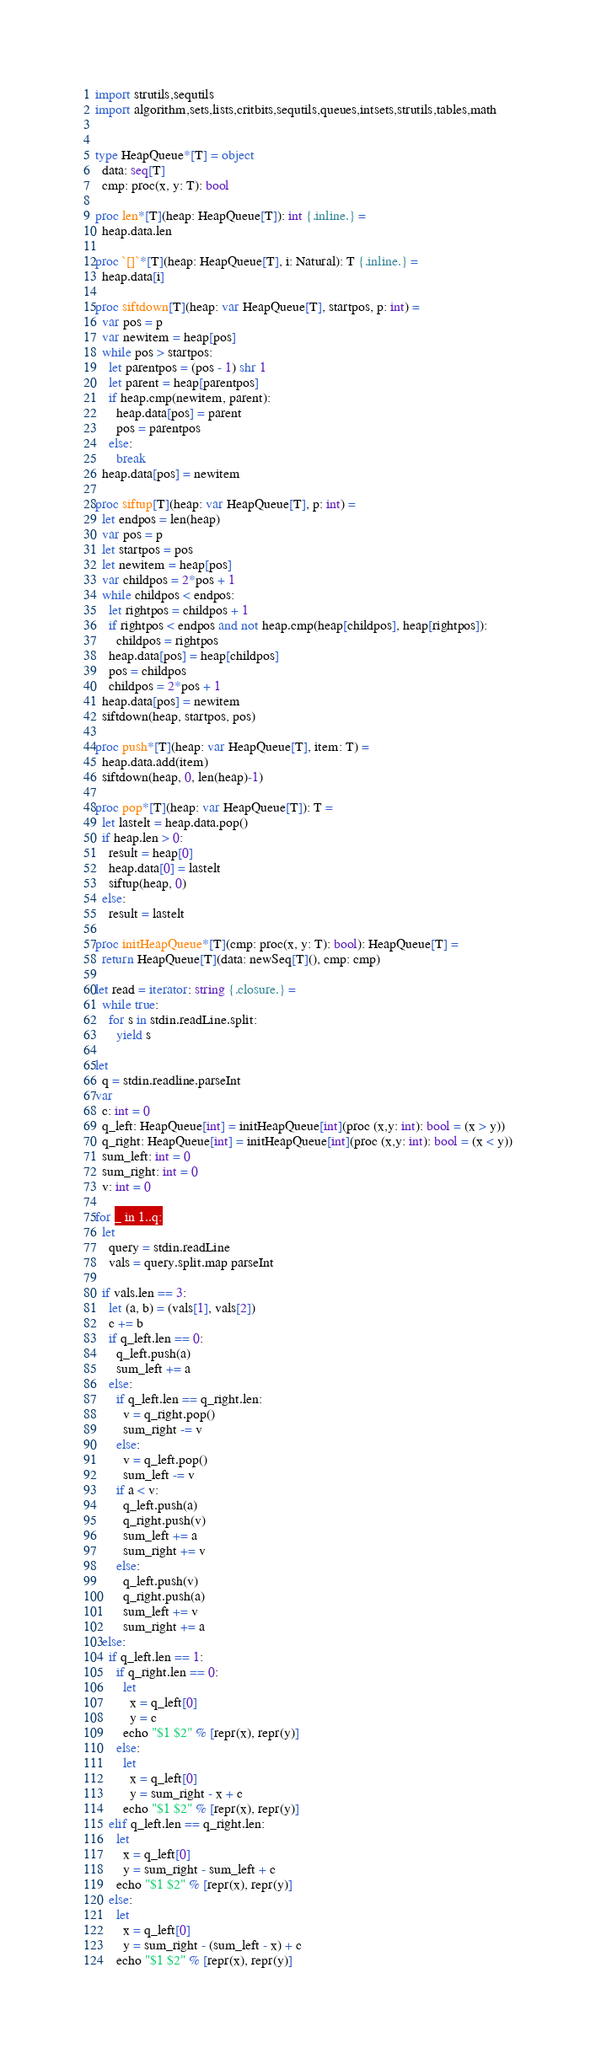<code> <loc_0><loc_0><loc_500><loc_500><_Nim_>import strutils,sequtils
import algorithm,sets,lists,critbits,sequtils,queues,intsets,strutils,tables,math


type HeapQueue*[T] = object
  data: seq[T]
  cmp: proc(x, y: T): bool

proc len*[T](heap: HeapQueue[T]): int {.inline.} =
  heap.data.len

proc `[]`*[T](heap: HeapQueue[T], i: Natural): T {.inline.} =
  heap.data[i]

proc siftdown[T](heap: var HeapQueue[T], startpos, p: int) =
  var pos = p
  var newitem = heap[pos]
  while pos > startpos:
    let parentpos = (pos - 1) shr 1
    let parent = heap[parentpos]
    if heap.cmp(newitem, parent):
      heap.data[pos] = parent
      pos = parentpos
    else:
      break
  heap.data[pos] = newitem

proc siftup[T](heap: var HeapQueue[T], p: int) =
  let endpos = len(heap)
  var pos = p
  let startpos = pos
  let newitem = heap[pos]
  var childpos = 2*pos + 1
  while childpos < endpos:
    let rightpos = childpos + 1
    if rightpos < endpos and not heap.cmp(heap[childpos], heap[rightpos]):
      childpos = rightpos
    heap.data[pos] = heap[childpos]
    pos = childpos
    childpos = 2*pos + 1
  heap.data[pos] = newitem
  siftdown(heap, startpos, pos)

proc push*[T](heap: var HeapQueue[T], item: T) =
  heap.data.add(item)
  siftdown(heap, 0, len(heap)-1)

proc pop*[T](heap: var HeapQueue[T]): T =
  let lastelt = heap.data.pop()
  if heap.len > 0:
    result = heap[0]
    heap.data[0] = lastelt
    siftup(heap, 0)
  else:
    result = lastelt

proc initHeapQueue*[T](cmp: proc(x, y: T): bool): HeapQueue[T] =
  return HeapQueue[T](data: newSeq[T](), cmp: cmp)

let read = iterator: string {.closure.} =
  while true:
    for s in stdin.readLine.split:
      yield s

let
  q = stdin.readline.parseInt
var
  c: int = 0
  q_left: HeapQueue[int] = initHeapQueue[int](proc (x,y: int): bool = (x > y))
  q_right: HeapQueue[int] = initHeapQueue[int](proc (x,y: int): bool = (x < y))
  sum_left: int = 0
  sum_right: int = 0
  v: int = 0

for _ in 1..q:
  let
    query = stdin.readLine
    vals = query.split.map parseInt
  
  if vals.len == 3:
    let (a, b) = (vals[1], vals[2])
    c += b
    if q_left.len == 0:
      q_left.push(a)
      sum_left += a
    else:
      if q_left.len == q_right.len:
        v = q_right.pop()
        sum_right -= v
      else:
        v = q_left.pop()
        sum_left -= v
      if a < v:
        q_left.push(a)
        q_right.push(v)
        sum_left += a
        sum_right += v
      else:
        q_left.push(v)
        q_right.push(a)
        sum_left += v
        sum_right += a
  else:
    if q_left.len == 1:
      if q_right.len == 0:
        let
          x = q_left[0]
          y = c
        echo "$1 $2" % [repr(x), repr(y)]
      else:
        let
          x = q_left[0]
          y = sum_right - x + c
        echo "$1 $2" % [repr(x), repr(y)]
    elif q_left.len == q_right.len:
      let
        x = q_left[0]
        y = sum_right - sum_left + c
      echo "$1 $2" % [repr(x), repr(y)]
    else:
      let
        x = q_left[0]
        y = sum_right - (sum_left - x) + c
      echo "$1 $2" % [repr(x), repr(y)]
</code> 